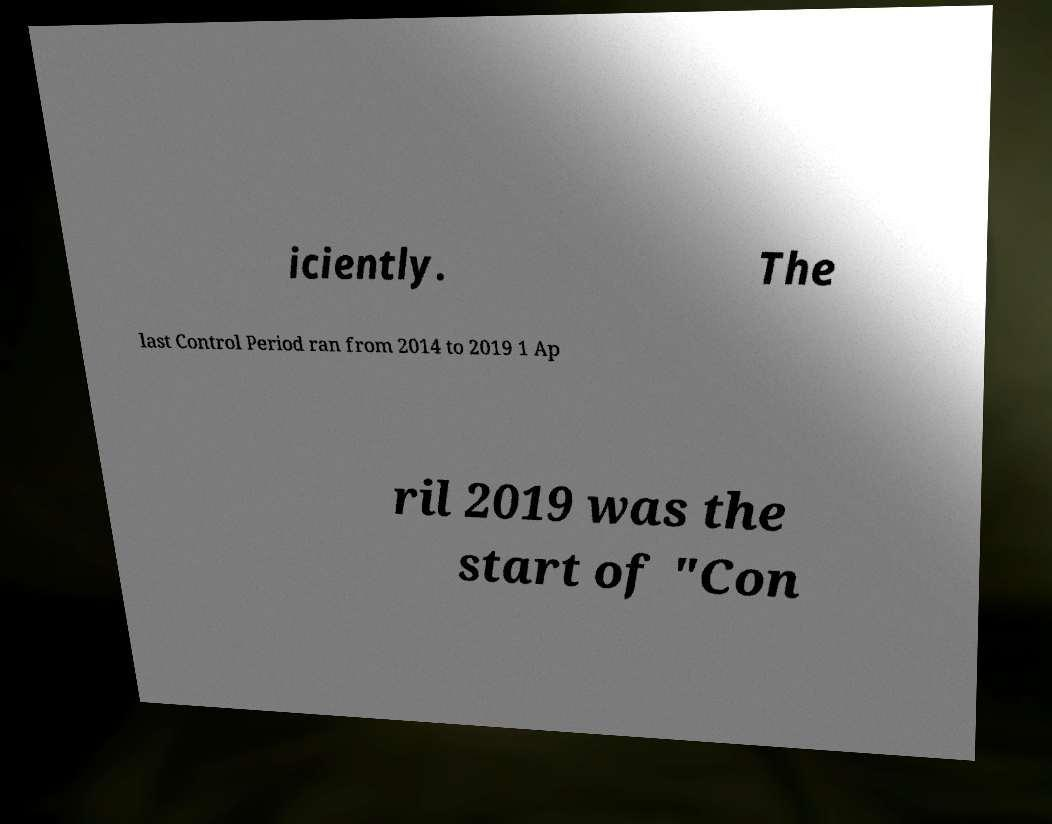Please identify and transcribe the text found in this image. iciently. The last Control Period ran from 2014 to 2019 1 Ap ril 2019 was the start of "Con 